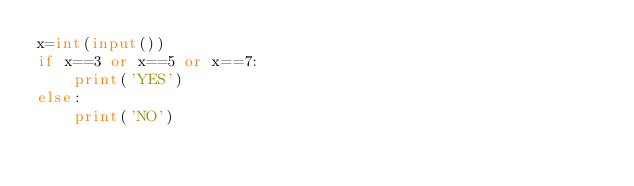<code> <loc_0><loc_0><loc_500><loc_500><_Python_>x=int(input())
if x==3 or x==5 or x==7:
    print('YES')
else:
    print('NO')</code> 